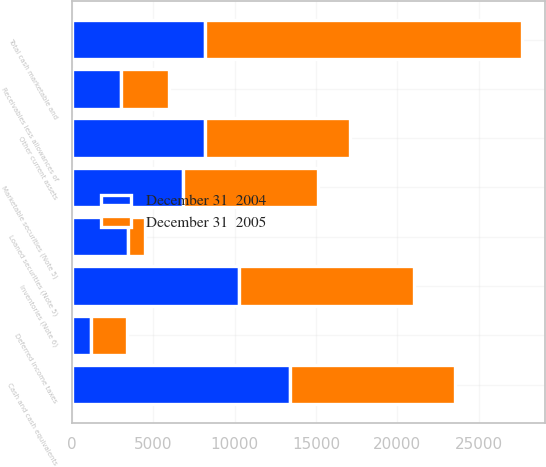Convert chart to OTSL. <chart><loc_0><loc_0><loc_500><loc_500><stacked_bar_chart><ecel><fcel>Cash and cash equivalents<fcel>Marketable securities (Note 5)<fcel>Loaned securities (Note 5)<fcel>Total cash marketable and<fcel>Receivables less allowances of<fcel>Inventories (Note 6)<fcel>Deferred income taxes<fcel>Other current assets<nl><fcel>December 31  2004<fcel>13392<fcel>6860<fcel>3461<fcel>8177<fcel>3061<fcel>10271<fcel>1187<fcel>8177<nl><fcel>December 31  2005<fcel>10142<fcel>8291<fcel>1058<fcel>19491<fcel>2894<fcel>10766<fcel>2200<fcel>8916<nl></chart> 